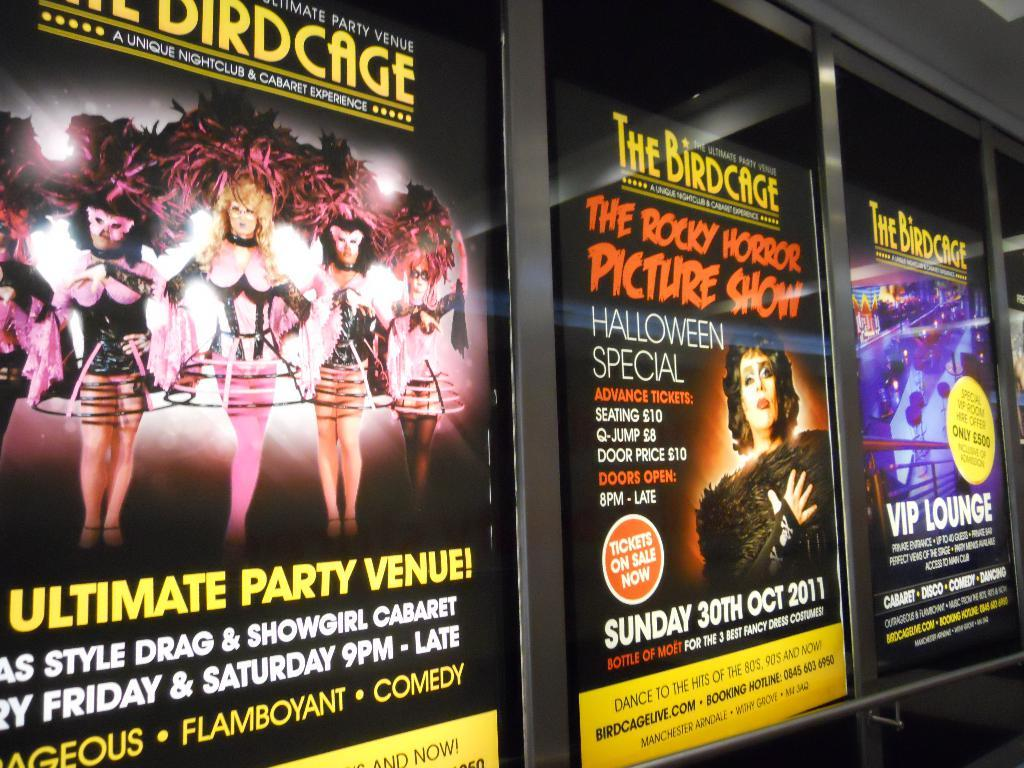<image>
Give a short and clear explanation of the subsequent image. Three posters in a row showing The Birdcage showings 